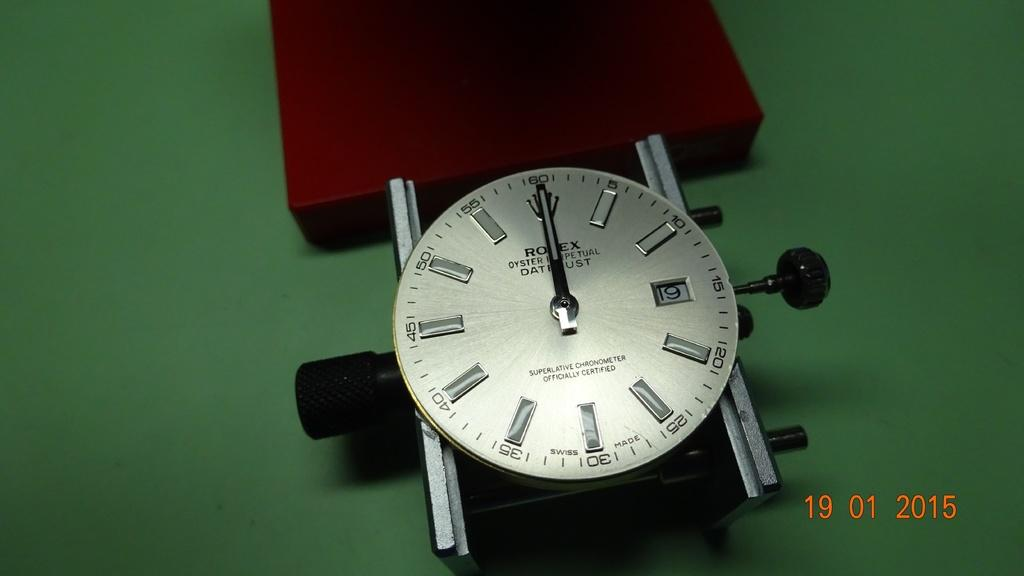What is the main object in the image? There is a clock in the image. What is the color of the surface on which the clock is placed? The clock is on a green surface. Are there any other colors present in the image besides green? Yes, there is a red color object in the image. What type of vessel is used for comfort in the image? There is no vessel or reference to comfort in the image; it only features a clock on a green surface and a red color object. 